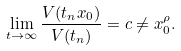Convert formula to latex. <formula><loc_0><loc_0><loc_500><loc_500>\lim _ { t \rightarrow \infty } \frac { V ( t _ { n } x _ { 0 } ) } { V ( t _ { n } ) } = c \neq x _ { 0 } ^ { \rho } .</formula> 